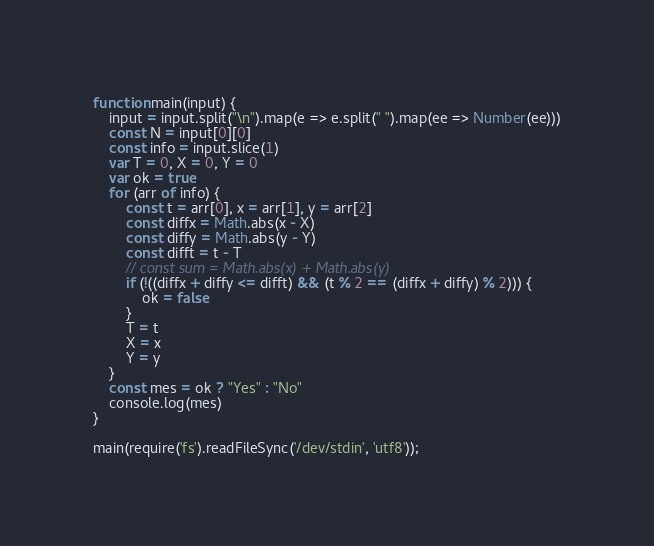Convert code to text. <code><loc_0><loc_0><loc_500><loc_500><_JavaScript_>function main(input) {
    input = input.split("\n").map(e => e.split(" ").map(ee => Number(ee)))
    const N = input[0][0]
    const info = input.slice(1)
    var T = 0, X = 0, Y = 0
    var ok = true
    for (arr of info) {
        const t = arr[0], x = arr[1], y = arr[2]
        const diffx = Math.abs(x - X)
        const diffy = Math.abs(y - Y)
        const difft = t - T
        // const sum = Math.abs(x) + Math.abs(y)
        if (!((diffx + diffy <= difft) && (t % 2 == (diffx + diffy) % 2))) {
            ok = false
        }
        T = t
        X = x
        Y = y
    }
    const mes = ok ? "Yes" : "No"
    console.log(mes)
}

main(require('fs').readFileSync('/dev/stdin', 'utf8'));
</code> 